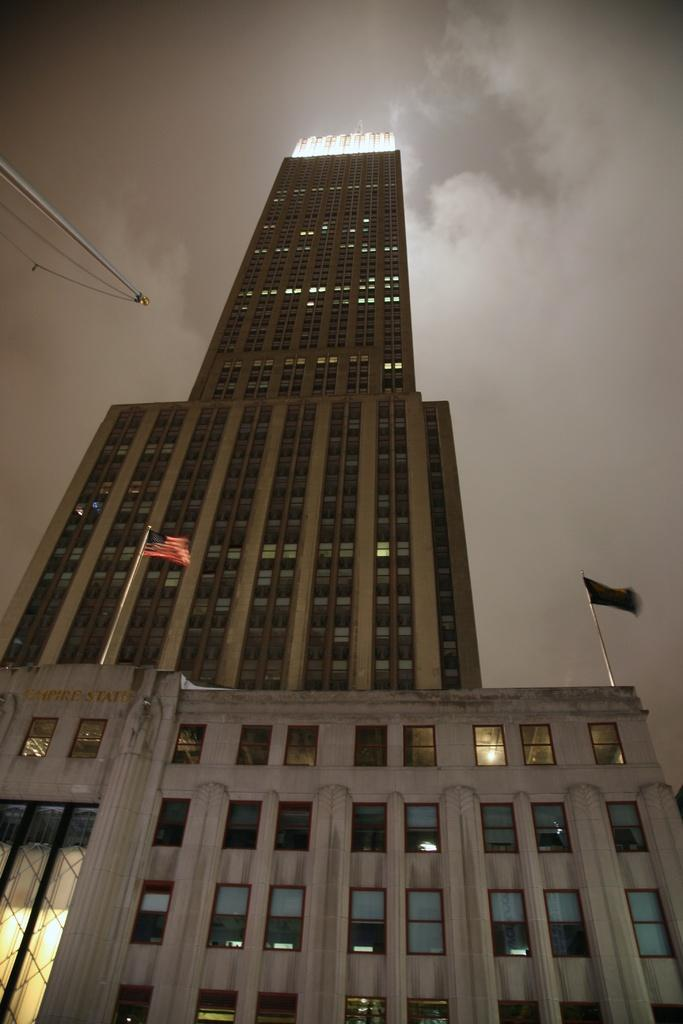What is located in the center of the image? There are buildings, flags, poles, windows, and lights in the center of the image. What can be seen on top of the poles in the image? Flags are on top of the poles in the image. What type of openings are present in the buildings? There are windows in the buildings in the image. What is illuminating the scene in the image? Lights are present in the center of the image. What is visible in the sky at the top of the image? Clouds are present in the sky at the top of the image. What type of metal is the heart made of in the image? There is no heart present in the image, so it is not possible to determine what type of metal it might be made of. 